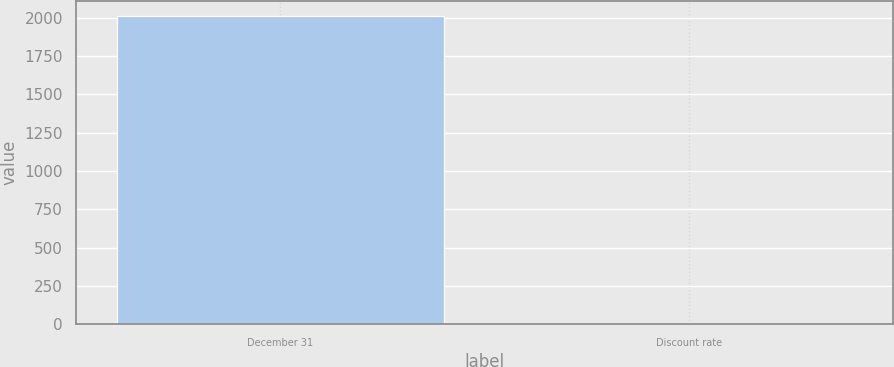<chart> <loc_0><loc_0><loc_500><loc_500><bar_chart><fcel>December 31<fcel>Discount rate<nl><fcel>2007<fcel>6<nl></chart> 